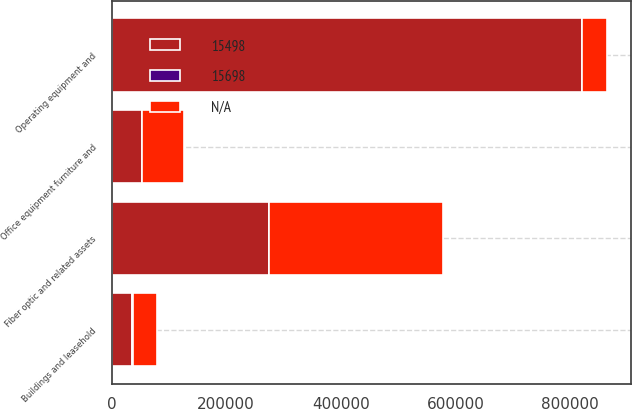Convert chart to OTSL. <chart><loc_0><loc_0><loc_500><loc_500><stacked_bar_chart><ecel><fcel>Buildings and leasehold<fcel>Operating equipment and<fcel>Fiber optic and related assets<fcel>Office equipment furniture and<nl><fcel>15698<fcel>530<fcel>525<fcel>520<fcel>315<nl><fcel>nan<fcel>42755<fcel>42755<fcel>303961<fcel>71955<nl><fcel>15498<fcel>36214<fcel>820024<fcel>273980<fcel>53322<nl></chart> 